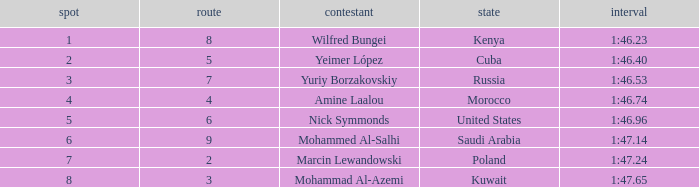What is the Rank of the Athlete with a Time of 1:47.65 and in Lane 3 or larger? None. 